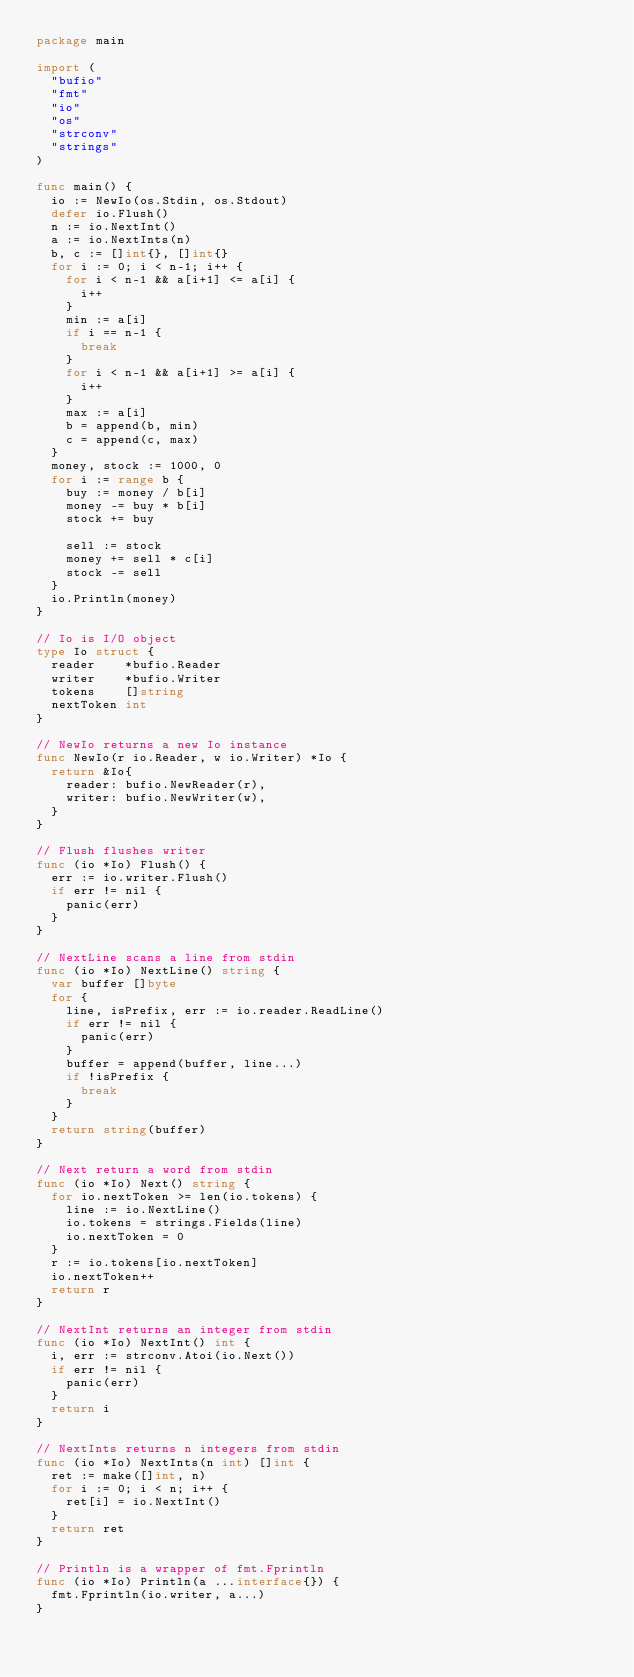Convert code to text. <code><loc_0><loc_0><loc_500><loc_500><_Go_>package main

import (
	"bufio"
	"fmt"
	"io"
	"os"
	"strconv"
	"strings"
)

func main() {
	io := NewIo(os.Stdin, os.Stdout)
	defer io.Flush()
	n := io.NextInt()
	a := io.NextInts(n)
	b, c := []int{}, []int{}
	for i := 0; i < n-1; i++ {
		for i < n-1 && a[i+1] <= a[i] {
			i++
		}
		min := a[i]
		if i == n-1 {
			break
		}
		for i < n-1 && a[i+1] >= a[i] {
			i++
		}
		max := a[i]
		b = append(b, min)
		c = append(c, max)
	}
	money, stock := 1000, 0
	for i := range b {
		buy := money / b[i]
		money -= buy * b[i]
		stock += buy

		sell := stock
		money += sell * c[i]
		stock -= sell
	}
	io.Println(money)
}

// Io is I/O object
type Io struct {
	reader    *bufio.Reader
	writer    *bufio.Writer
	tokens    []string
	nextToken int
}

// NewIo returns a new Io instance
func NewIo(r io.Reader, w io.Writer) *Io {
	return &Io{
		reader: bufio.NewReader(r),
		writer: bufio.NewWriter(w),
	}
}

// Flush flushes writer
func (io *Io) Flush() {
	err := io.writer.Flush()
	if err != nil {
		panic(err)
	}
}

// NextLine scans a line from stdin
func (io *Io) NextLine() string {
	var buffer []byte
	for {
		line, isPrefix, err := io.reader.ReadLine()
		if err != nil {
			panic(err)
		}
		buffer = append(buffer, line...)
		if !isPrefix {
			break
		}
	}
	return string(buffer)
}

// Next return a word from stdin
func (io *Io) Next() string {
	for io.nextToken >= len(io.tokens) {
		line := io.NextLine()
		io.tokens = strings.Fields(line)
		io.nextToken = 0
	}
	r := io.tokens[io.nextToken]
	io.nextToken++
	return r
}

// NextInt returns an integer from stdin
func (io *Io) NextInt() int {
	i, err := strconv.Atoi(io.Next())
	if err != nil {
		panic(err)
	}
	return i
}

// NextInts returns n integers from stdin
func (io *Io) NextInts(n int) []int {
	ret := make([]int, n)
	for i := 0; i < n; i++ {
		ret[i] = io.NextInt()
	}
	return ret
}

// Println is a wrapper of fmt.Fprintln
func (io *Io) Println(a ...interface{}) {
	fmt.Fprintln(io.writer, a...)
}
</code> 